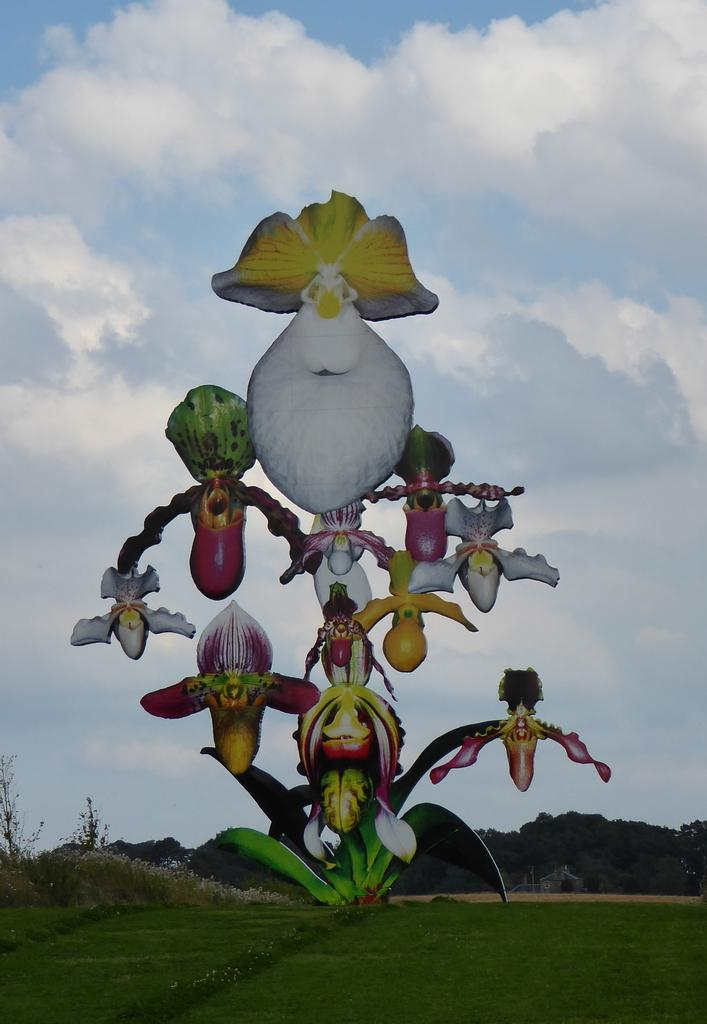What can be seen in the sky in the image? There are clouds in the sky in the image. What type of vegetation is present in the image? There are trees, plants, and grass in the image. Can you describe the craft in the image? There is a craft of a plant in the image. What type of news can be seen on the trees in the image? There is no news present in the image; it only features trees, plants, grass, and a craft of a plant. How many apples are visible on the grass in the image? There are no apples present in the image; it only features trees, plants, grass, and a craft of a plant. Can you describe the chess game being played on the craft of a plant in the image? There is no chess game present in the image; it only features trees, plants, grass, and a craft of a plant. 